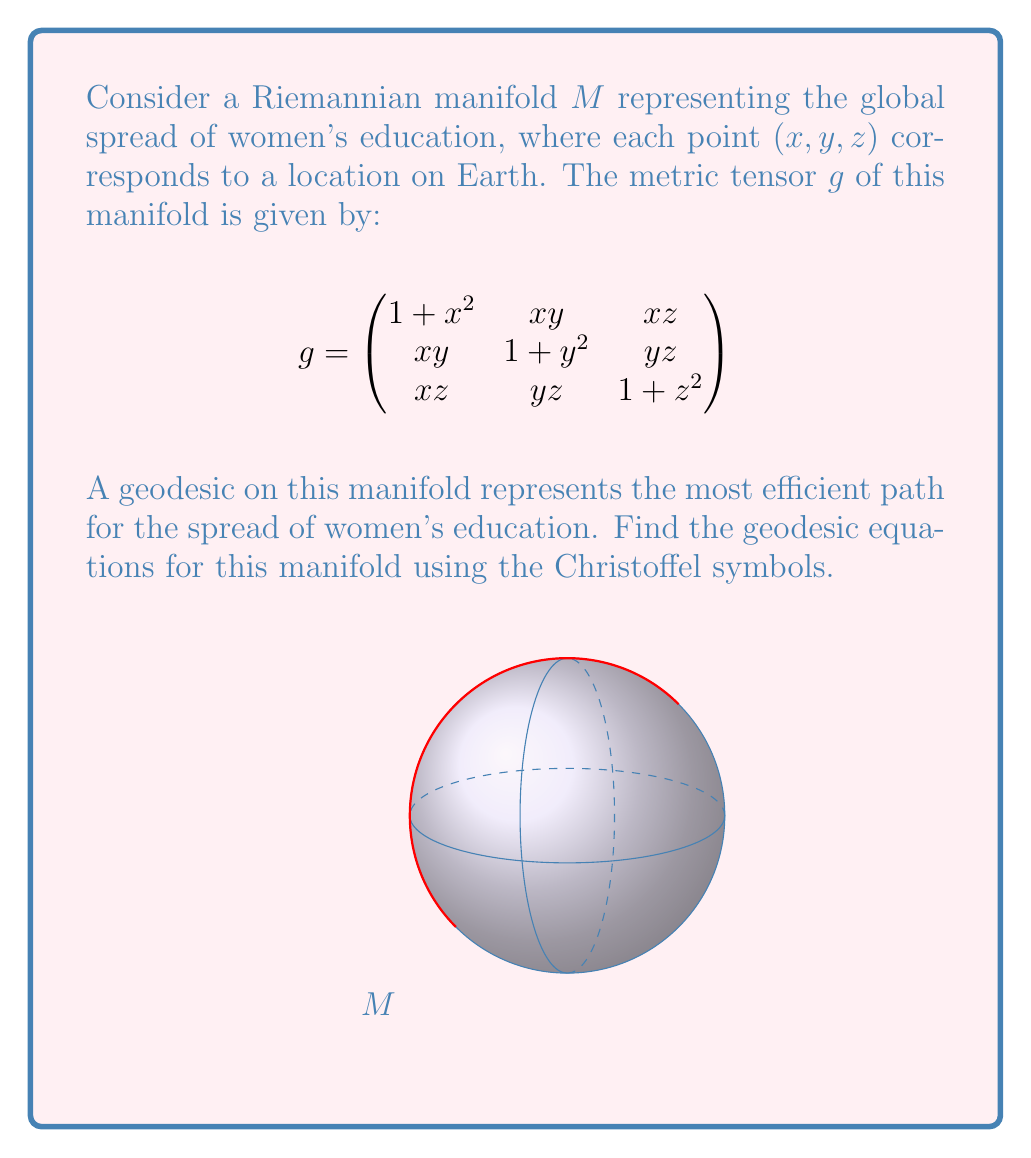Help me with this question. To find the geodesic equations, we need to follow these steps:

1) Calculate the Christoffel symbols $\Gamma^k_{ij}$ using the formula:

   $$\Gamma^k_{ij} = \frac{1}{2}g^{kl}(\partial_i g_{jl} + \partial_j g_{il} - \partial_l g_{ij})$$

2) The inverse metric tensor $g^{-1}$ is:

   $$g^{-1} = \frac{1}{1+x^2+y^2+z^2}\begin{pmatrix}
   1+y^2+z^2 & -xy & -xz \\
   -xy & 1+x^2+z^2 & -yz \\
   -xz & -yz & 1+x^2+y^2
   \end{pmatrix}$$

3) Calculate the partial derivatives of $g_{ij}$:

   $\partial_x g_{11} = 2x$, $\partial_y g_{12} = x$, $\partial_z g_{13} = x$, etc.

4) Substitute these into the Christoffel symbol formula. For example:

   $$\Gamma^1_{11} = \frac{1}{2}(g^{11}(2x) + g^{12}(x) + g^{13}(x) - g^{11}(2x)) = \frac{x(1+y^2+z^2)}{1+x^2+y^2+z^2}$$

5) The geodesic equations are:

   $$\frac{d^2x^k}{ds^2} + \Gamma^k_{ij}\frac{dx^i}{ds}\frac{dx^j}{ds} = 0$$

6) Substituting the Christoffel symbols, we get the geodesic equations:

   $$\frac{d^2x}{ds^2} + \frac{x((1+y^2+z^2)(\frac{dx}{ds})^2 - xy(\frac{dy}{ds})^2 - xz(\frac{dz}{ds})^2)}{1+x^2+y^2+z^2} = 0$$

   $$\frac{d^2y}{ds^2} + \frac{y((1+x^2+z^2)(\frac{dy}{ds})^2 - xy(\frac{dx}{ds})^2 - yz(\frac{dz}{ds})^2)}{1+x^2+y^2+z^2} = 0$$

   $$\frac{d^2z}{ds^2} + \frac{z((1+x^2+y^2)(\frac{dz}{ds})^2 - xz(\frac{dx}{ds})^2 - yz(\frac{dy}{ds})^2)}{1+x^2+y^2+z^2} = 0$$
Answer: $$\frac{d^2x^k}{ds^2} + \frac{x^k((1+\sum_{i\neq k}(x^i)^2)(\frac{dx^k}{ds})^2 - \sum_{i\neq k}x^kx^i(\frac{dx^i}{ds})^2)}{1+x^2+y^2+z^2} = 0$$
for $k = 1,2,3$ and $(x^1,x^2,x^3) = (x,y,z)$ 